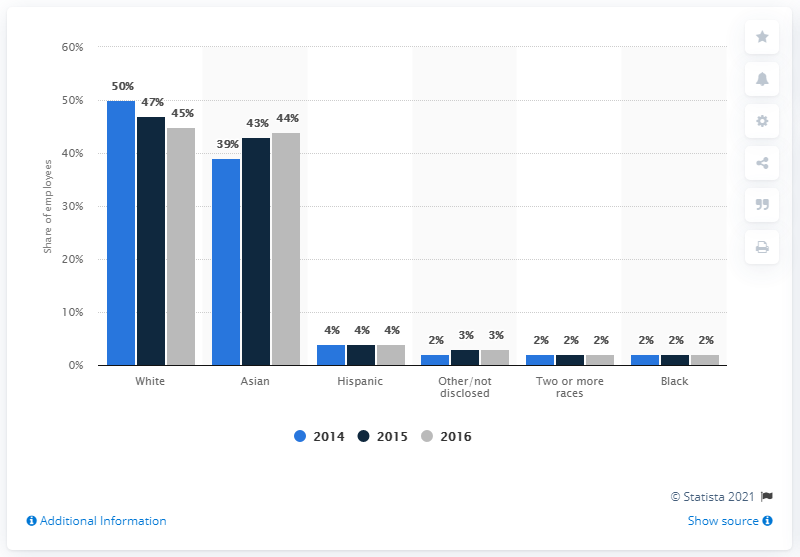Draw attention to some important aspects in this diagram. In the last reported period, four percent of Yahoo employees identified as Hispanic. 